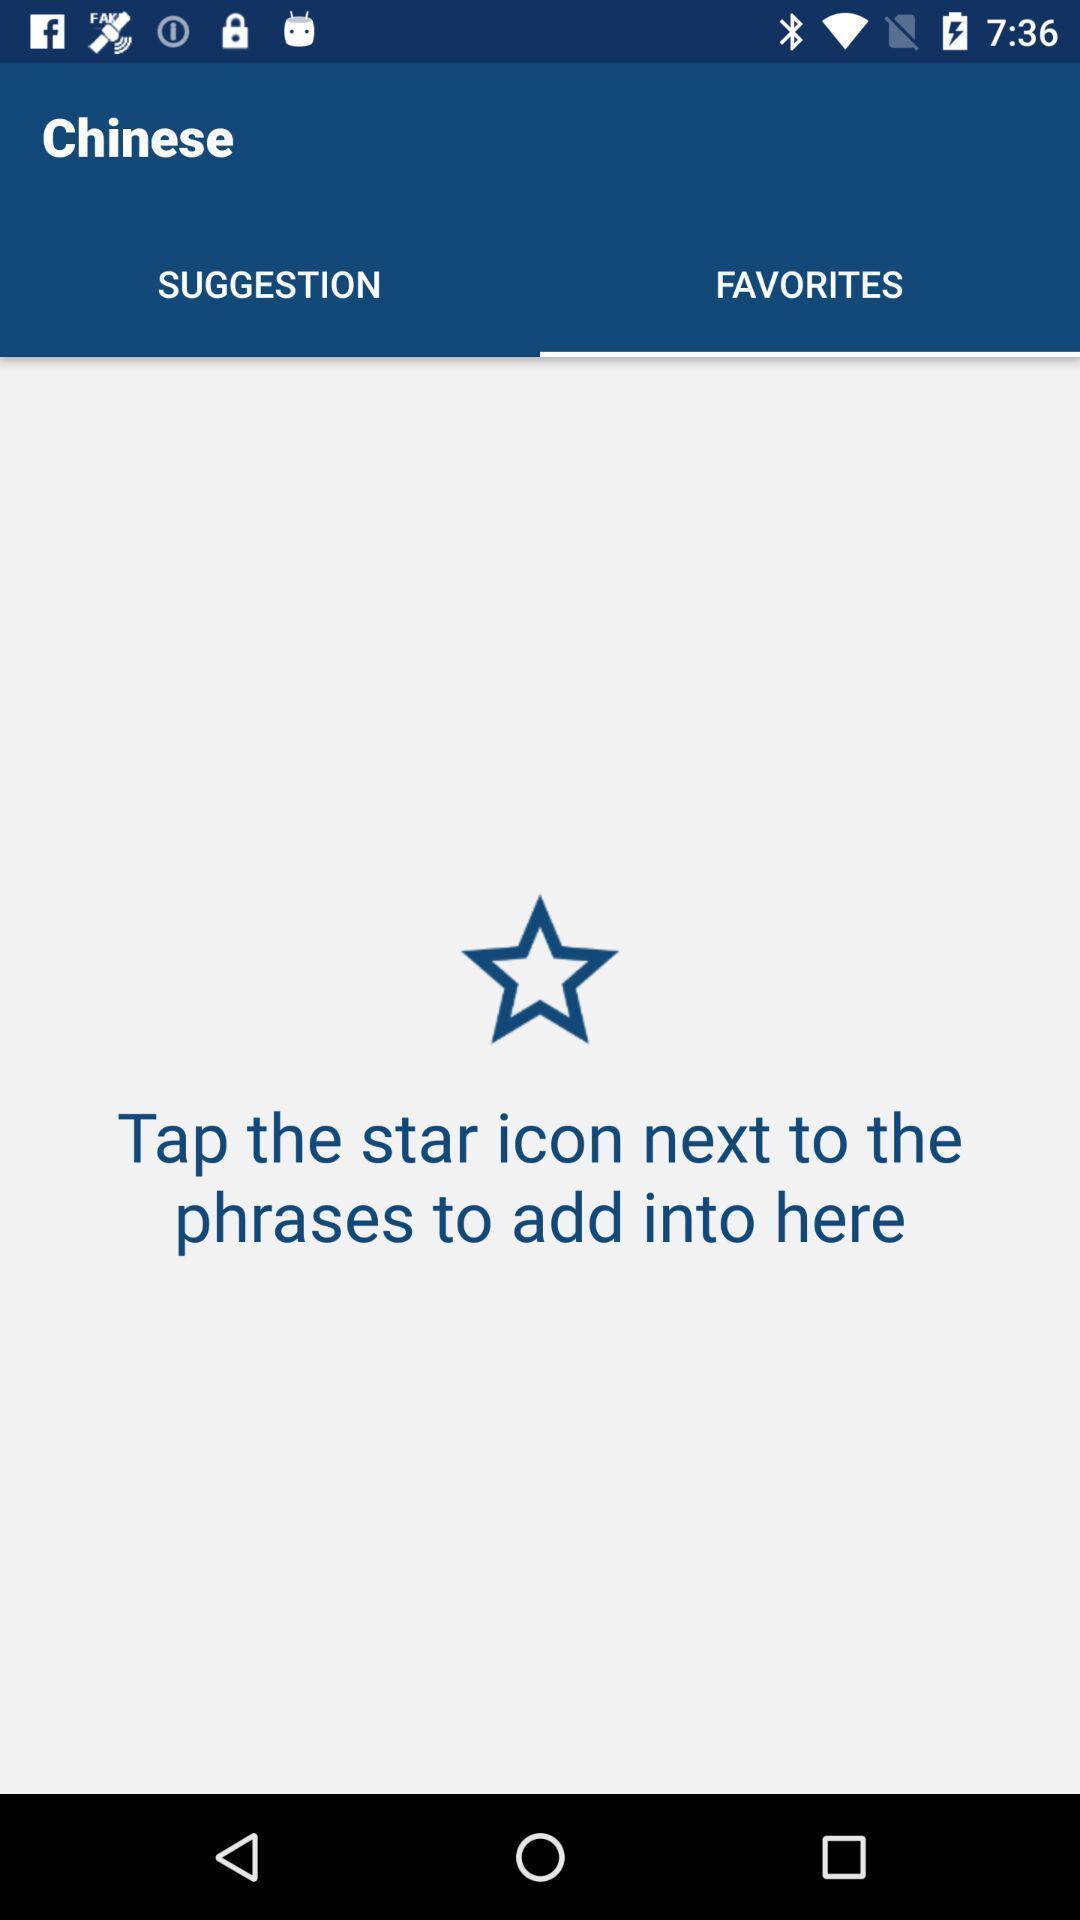What details can you identify in this image? Screen displaying the blank page in favorites tab. 